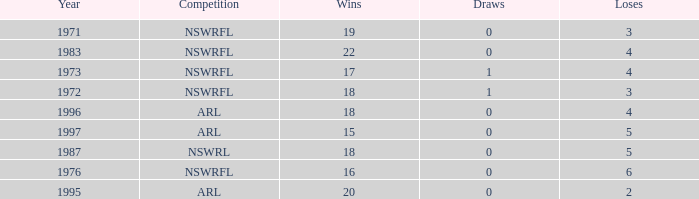What sum of Losses has Year greater than 1972, and Competition of nswrfl, and Draws 0, and Wins 16? 6.0. 